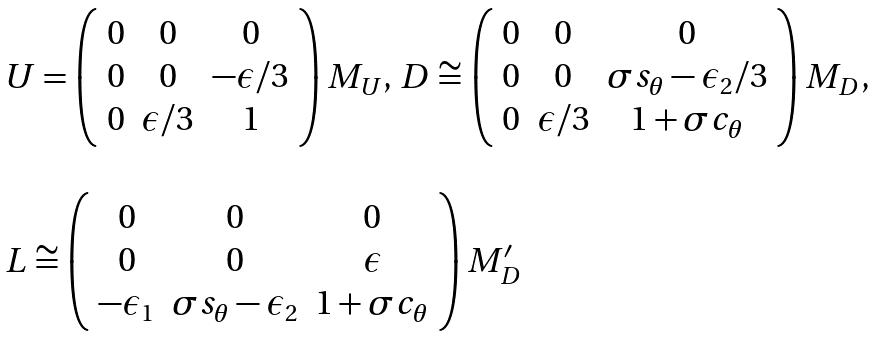<formula> <loc_0><loc_0><loc_500><loc_500>\begin{array} { l } U = \left ( \begin{array} { c c c } 0 & 0 & 0 \\ 0 & 0 & - \epsilon / 3 \\ 0 & \epsilon / 3 & 1 \end{array} \right ) M _ { U } , \, D \cong \left ( \begin{array} { c c c } 0 & 0 & 0 \\ 0 & 0 & \sigma s _ { \theta } - \epsilon _ { 2 } / 3 \\ 0 & \epsilon / 3 & 1 + \sigma c _ { \theta } \end{array} \right ) M _ { D } , \\ \\ L \cong \left ( \begin{array} { c c c } 0 & 0 & 0 \\ 0 & 0 & \epsilon \\ - \epsilon _ { 1 } & \sigma s _ { \theta } - \epsilon _ { 2 } & 1 + \sigma c _ { \theta } \end{array} \right ) M _ { D } ^ { \prime } \end{array}</formula> 